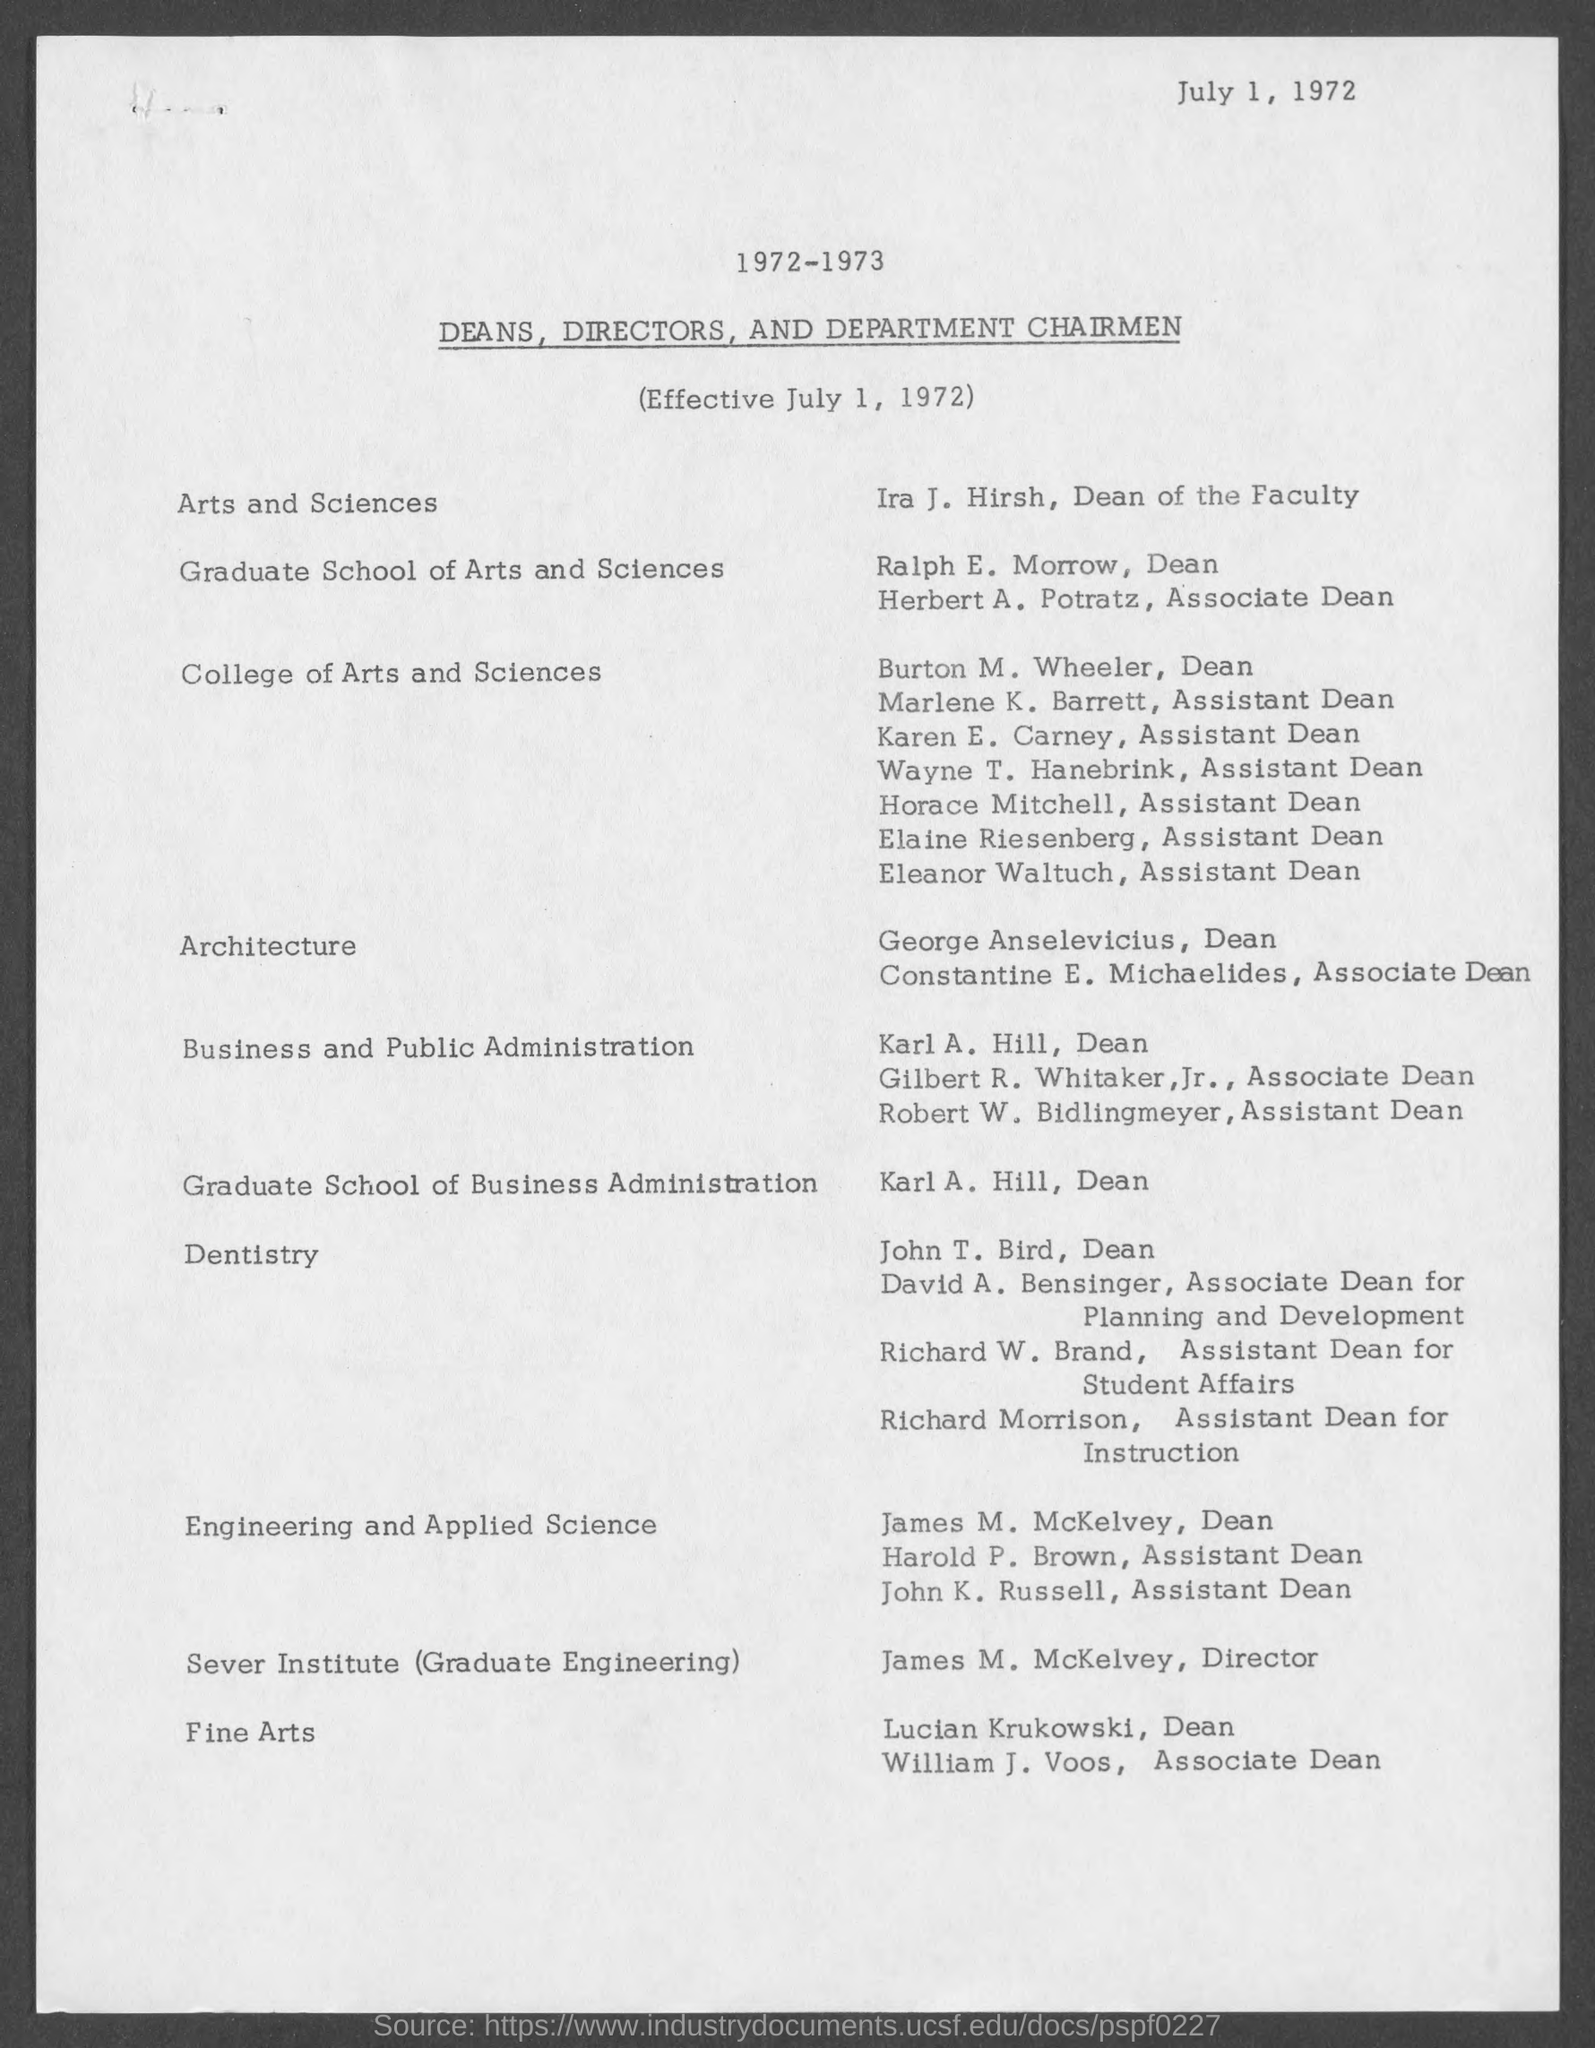Draw attention to some important aspects in this diagram. Karen E. Carney holds the position of Assistant Dean. Burton M. Wheeler is the Dean of [insert name of organization/institution]. Marlene K. Barrett is the Assistant Dean. Ira J. Hirsh currently serves as the Dean of the Faculty at [insert location]. Eleanor Waltuch is the Assistant Dean at a certain location. 